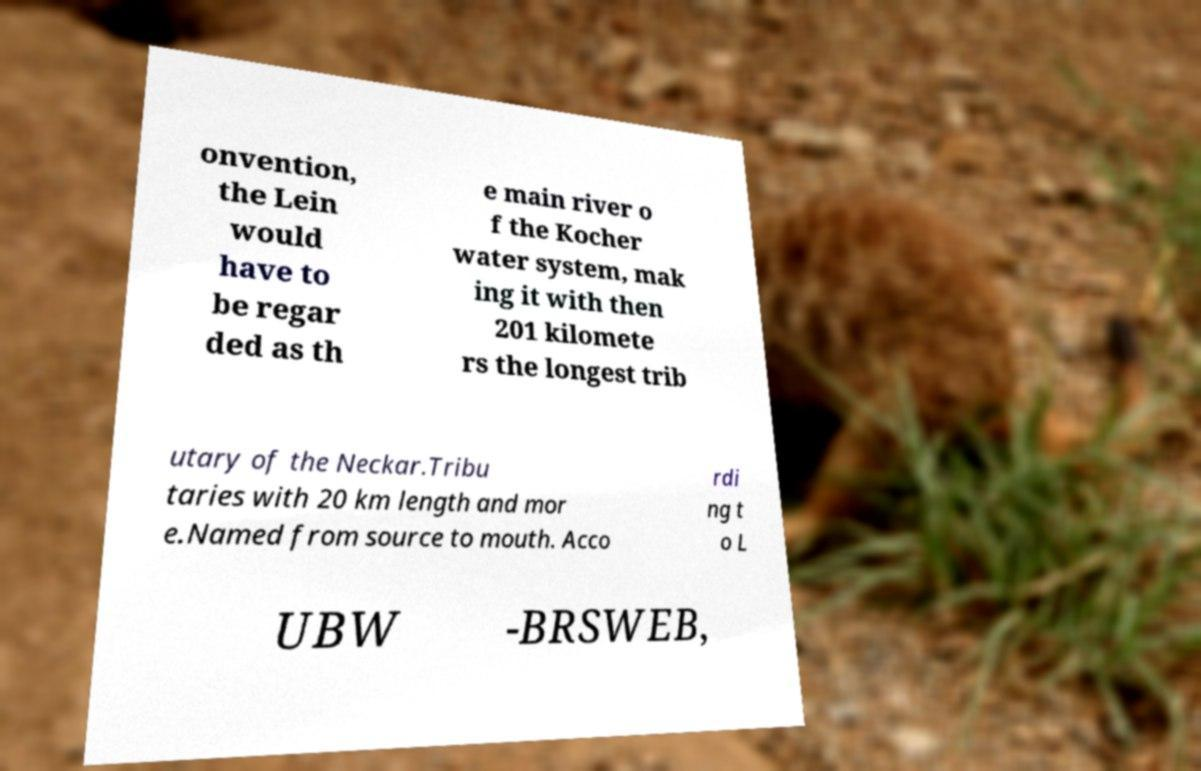Please identify and transcribe the text found in this image. onvention, the Lein would have to be regar ded as th e main river o f the Kocher water system, mak ing it with then 201 kilomete rs the longest trib utary of the Neckar.Tribu taries with 20 km length and mor e.Named from source to mouth. Acco rdi ng t o L UBW -BRSWEB, 